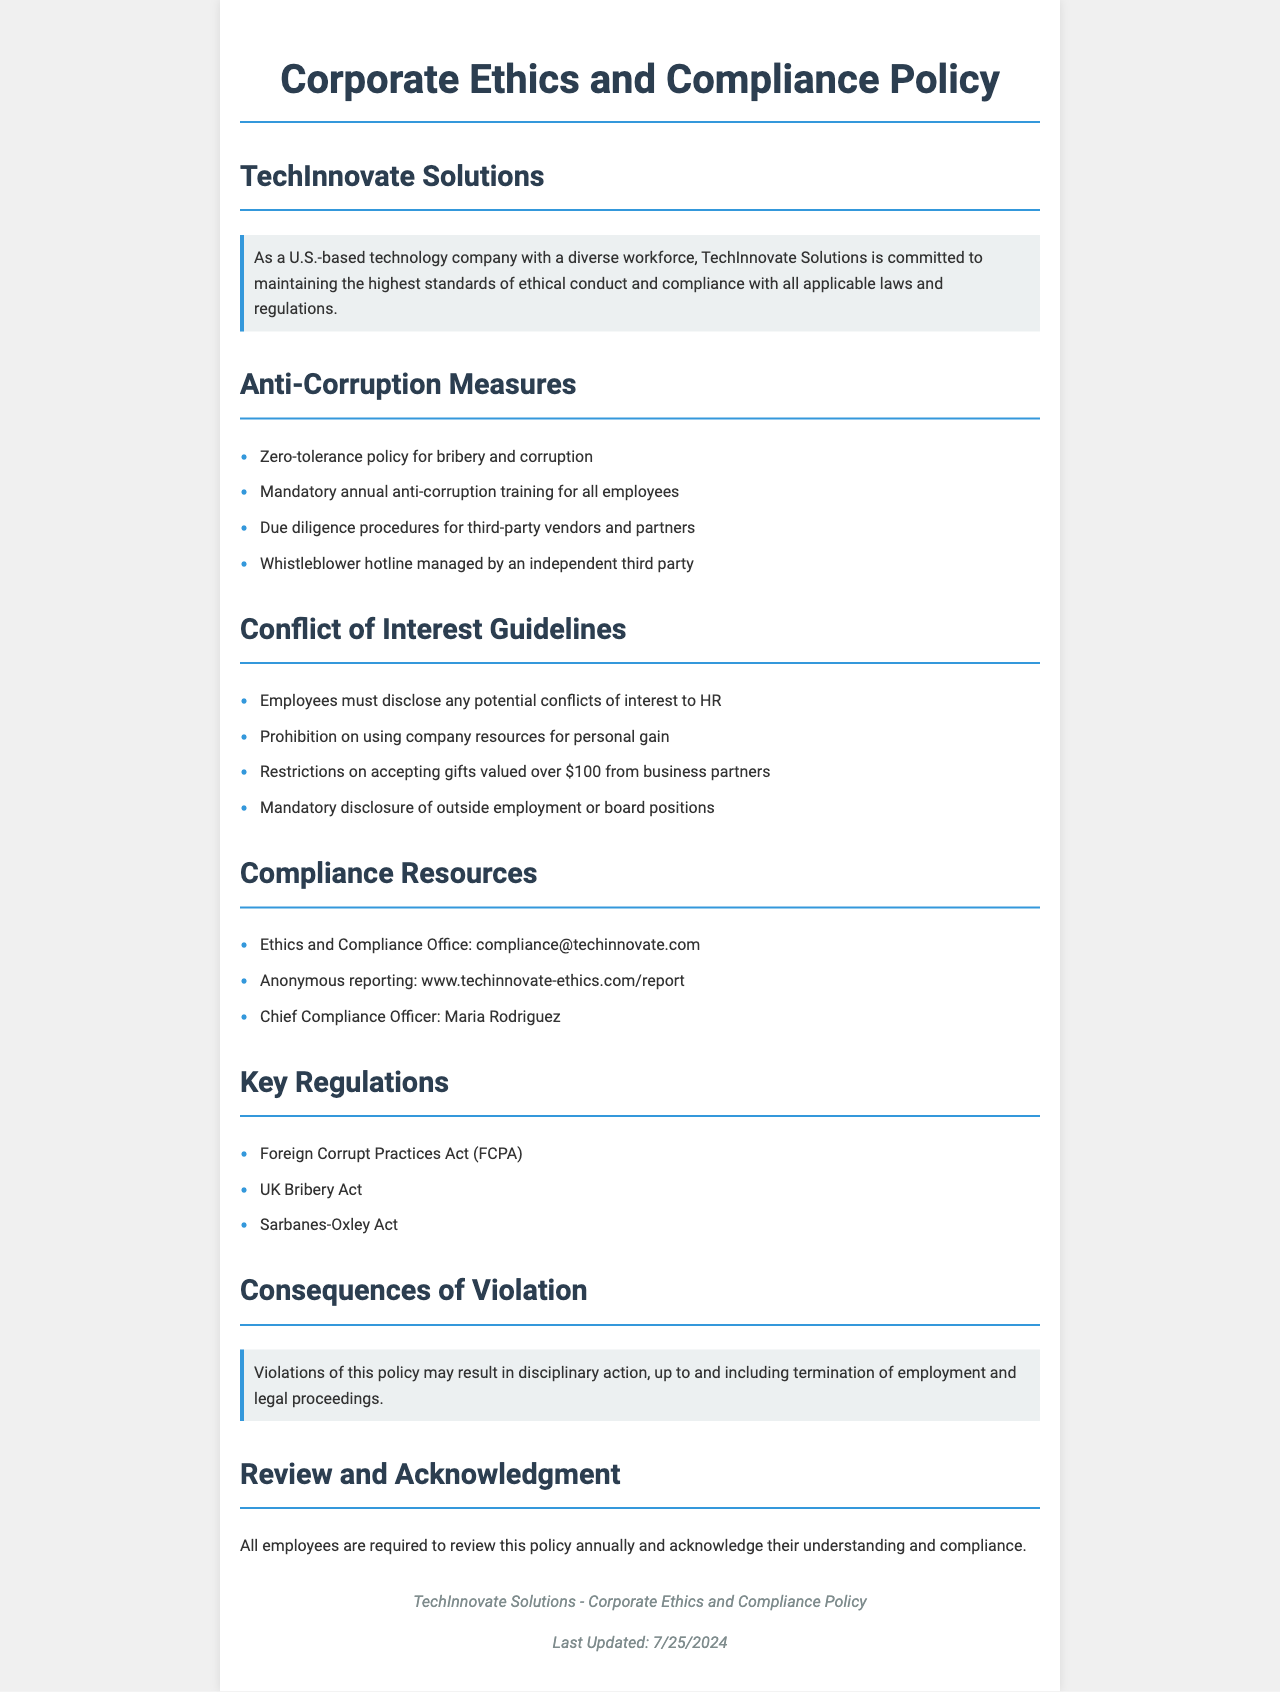What is the name of the Chief Compliance Officer? The Chief Compliance Officer's name is mentioned in the document as a specific individual responsible for compliance matters.
Answer: Maria Rodriguez What is the maximum value of gifts employees can accept from business partners? This value is specified in the conflict of interest guidelines section of the document, reflecting the company's stance on gifts.
Answer: $100 What is the policy regarding bribery and corruption? The document clearly states the approach toward corruption, highlighting the company’s stance and expectations.
Answer: Zero-tolerance policy What must employees do regarding potential conflicts of interest? This requirement is detailed in the conflict of interest guidelines, outlining the necessary actions employees must take when faced with such situations.
Answer: Disclose to HR What is the purpose of the whistleblower hotline? The purpose is defined in the anti-corruption measures section, emphasizing its role in reporting unethical behavior.
Answer: Reporting unethical behavior How often is mandatory anti-corruption training required? This frequency is indicated in the anti-corruption measures section, specifying the regularity of training for employees.
Answer: Annually What are the consequences of policy violations? The document states the repercussions that may arise from failing to adhere to the policy, indicating the seriousness of compliance.
Answer: Disciplinary action What is an example of a key regulation mentioned? This demonstrates the legal context within which the policy operates, providing a framework for compliance.
Answer: Foreign Corrupt Practices Act What must employees do with the policy annually? This requirement is specified in the review and acknowledgment section, outlining employee responsibilities each year.
Answer: Acknowledge understanding and compliance 